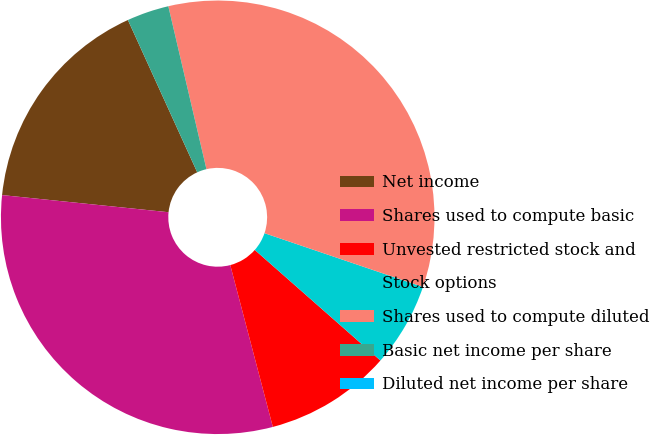<chart> <loc_0><loc_0><loc_500><loc_500><pie_chart><fcel>Net income<fcel>Shares used to compute basic<fcel>Unvested restricted stock and<fcel>Stock options<fcel>Shares used to compute diluted<fcel>Basic net income per share<fcel>Diluted net income per share<nl><fcel>16.57%<fcel>30.73%<fcel>9.42%<fcel>6.28%<fcel>33.87%<fcel>3.14%<fcel>0.0%<nl></chart> 